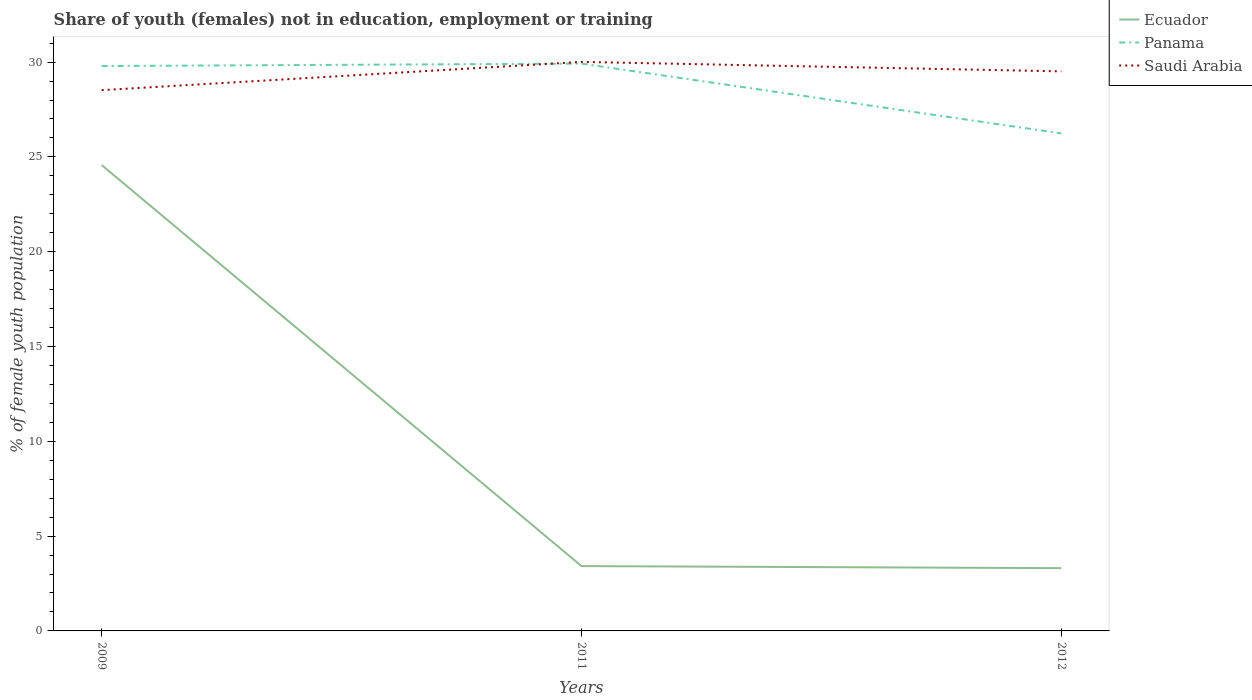How many different coloured lines are there?
Provide a short and direct response. 3. Does the line corresponding to Ecuador intersect with the line corresponding to Saudi Arabia?
Your answer should be very brief. No. Across all years, what is the maximum percentage of unemployed female population in in Saudi Arabia?
Offer a terse response. 28.52. What is the total percentage of unemployed female population in in Saudi Arabia in the graph?
Give a very brief answer. 0.5. What is the difference between the highest and the second highest percentage of unemployed female population in in Panama?
Give a very brief answer. 3.68. What is the difference between the highest and the lowest percentage of unemployed female population in in Ecuador?
Your response must be concise. 1. Does the graph contain any zero values?
Keep it short and to the point. No. Where does the legend appear in the graph?
Keep it short and to the point. Top right. How many legend labels are there?
Your answer should be compact. 3. What is the title of the graph?
Provide a short and direct response. Share of youth (females) not in education, employment or training. What is the label or title of the X-axis?
Offer a terse response. Years. What is the label or title of the Y-axis?
Ensure brevity in your answer.  % of female youth population. What is the % of female youth population of Ecuador in 2009?
Keep it short and to the point. 24.57. What is the % of female youth population of Panama in 2009?
Your answer should be very brief. 29.79. What is the % of female youth population in Saudi Arabia in 2009?
Provide a short and direct response. 28.52. What is the % of female youth population of Ecuador in 2011?
Keep it short and to the point. 3.42. What is the % of female youth population in Panama in 2011?
Offer a terse response. 29.92. What is the % of female youth population in Saudi Arabia in 2011?
Offer a terse response. 30.01. What is the % of female youth population in Ecuador in 2012?
Provide a succinct answer. 3.31. What is the % of female youth population of Panama in 2012?
Offer a very short reply. 26.24. What is the % of female youth population of Saudi Arabia in 2012?
Make the answer very short. 29.51. Across all years, what is the maximum % of female youth population of Ecuador?
Your response must be concise. 24.57. Across all years, what is the maximum % of female youth population in Panama?
Your answer should be compact. 29.92. Across all years, what is the maximum % of female youth population in Saudi Arabia?
Offer a very short reply. 30.01. Across all years, what is the minimum % of female youth population of Ecuador?
Provide a succinct answer. 3.31. Across all years, what is the minimum % of female youth population of Panama?
Offer a terse response. 26.24. Across all years, what is the minimum % of female youth population of Saudi Arabia?
Ensure brevity in your answer.  28.52. What is the total % of female youth population of Ecuador in the graph?
Offer a very short reply. 31.3. What is the total % of female youth population in Panama in the graph?
Give a very brief answer. 85.95. What is the total % of female youth population in Saudi Arabia in the graph?
Offer a terse response. 88.04. What is the difference between the % of female youth population in Ecuador in 2009 and that in 2011?
Offer a very short reply. 21.15. What is the difference between the % of female youth population in Panama in 2009 and that in 2011?
Ensure brevity in your answer.  -0.13. What is the difference between the % of female youth population of Saudi Arabia in 2009 and that in 2011?
Ensure brevity in your answer.  -1.49. What is the difference between the % of female youth population in Ecuador in 2009 and that in 2012?
Your answer should be very brief. 21.26. What is the difference between the % of female youth population of Panama in 2009 and that in 2012?
Provide a succinct answer. 3.55. What is the difference between the % of female youth population in Saudi Arabia in 2009 and that in 2012?
Provide a short and direct response. -0.99. What is the difference between the % of female youth population in Ecuador in 2011 and that in 2012?
Your answer should be very brief. 0.11. What is the difference between the % of female youth population of Panama in 2011 and that in 2012?
Provide a succinct answer. 3.68. What is the difference between the % of female youth population of Ecuador in 2009 and the % of female youth population of Panama in 2011?
Offer a very short reply. -5.35. What is the difference between the % of female youth population of Ecuador in 2009 and the % of female youth population of Saudi Arabia in 2011?
Your answer should be compact. -5.44. What is the difference between the % of female youth population of Panama in 2009 and the % of female youth population of Saudi Arabia in 2011?
Provide a short and direct response. -0.22. What is the difference between the % of female youth population of Ecuador in 2009 and the % of female youth population of Panama in 2012?
Make the answer very short. -1.67. What is the difference between the % of female youth population in Ecuador in 2009 and the % of female youth population in Saudi Arabia in 2012?
Ensure brevity in your answer.  -4.94. What is the difference between the % of female youth population in Panama in 2009 and the % of female youth population in Saudi Arabia in 2012?
Your answer should be very brief. 0.28. What is the difference between the % of female youth population of Ecuador in 2011 and the % of female youth population of Panama in 2012?
Give a very brief answer. -22.82. What is the difference between the % of female youth population of Ecuador in 2011 and the % of female youth population of Saudi Arabia in 2012?
Ensure brevity in your answer.  -26.09. What is the difference between the % of female youth population in Panama in 2011 and the % of female youth population in Saudi Arabia in 2012?
Offer a terse response. 0.41. What is the average % of female youth population in Ecuador per year?
Your answer should be very brief. 10.43. What is the average % of female youth population of Panama per year?
Provide a short and direct response. 28.65. What is the average % of female youth population in Saudi Arabia per year?
Provide a short and direct response. 29.35. In the year 2009, what is the difference between the % of female youth population of Ecuador and % of female youth population of Panama?
Offer a very short reply. -5.22. In the year 2009, what is the difference between the % of female youth population of Ecuador and % of female youth population of Saudi Arabia?
Offer a very short reply. -3.95. In the year 2009, what is the difference between the % of female youth population in Panama and % of female youth population in Saudi Arabia?
Your response must be concise. 1.27. In the year 2011, what is the difference between the % of female youth population of Ecuador and % of female youth population of Panama?
Give a very brief answer. -26.5. In the year 2011, what is the difference between the % of female youth population in Ecuador and % of female youth population in Saudi Arabia?
Offer a very short reply. -26.59. In the year 2011, what is the difference between the % of female youth population of Panama and % of female youth population of Saudi Arabia?
Your response must be concise. -0.09. In the year 2012, what is the difference between the % of female youth population of Ecuador and % of female youth population of Panama?
Keep it short and to the point. -22.93. In the year 2012, what is the difference between the % of female youth population in Ecuador and % of female youth population in Saudi Arabia?
Offer a very short reply. -26.2. In the year 2012, what is the difference between the % of female youth population of Panama and % of female youth population of Saudi Arabia?
Offer a terse response. -3.27. What is the ratio of the % of female youth population in Ecuador in 2009 to that in 2011?
Your answer should be compact. 7.18. What is the ratio of the % of female youth population of Panama in 2009 to that in 2011?
Your answer should be very brief. 1. What is the ratio of the % of female youth population of Saudi Arabia in 2009 to that in 2011?
Give a very brief answer. 0.95. What is the ratio of the % of female youth population in Ecuador in 2009 to that in 2012?
Keep it short and to the point. 7.42. What is the ratio of the % of female youth population in Panama in 2009 to that in 2012?
Offer a terse response. 1.14. What is the ratio of the % of female youth population in Saudi Arabia in 2009 to that in 2012?
Ensure brevity in your answer.  0.97. What is the ratio of the % of female youth population in Ecuador in 2011 to that in 2012?
Ensure brevity in your answer.  1.03. What is the ratio of the % of female youth population of Panama in 2011 to that in 2012?
Ensure brevity in your answer.  1.14. What is the ratio of the % of female youth population of Saudi Arabia in 2011 to that in 2012?
Offer a terse response. 1.02. What is the difference between the highest and the second highest % of female youth population of Ecuador?
Offer a very short reply. 21.15. What is the difference between the highest and the second highest % of female youth population in Panama?
Your response must be concise. 0.13. What is the difference between the highest and the lowest % of female youth population in Ecuador?
Provide a short and direct response. 21.26. What is the difference between the highest and the lowest % of female youth population in Panama?
Your answer should be very brief. 3.68. What is the difference between the highest and the lowest % of female youth population in Saudi Arabia?
Your answer should be compact. 1.49. 